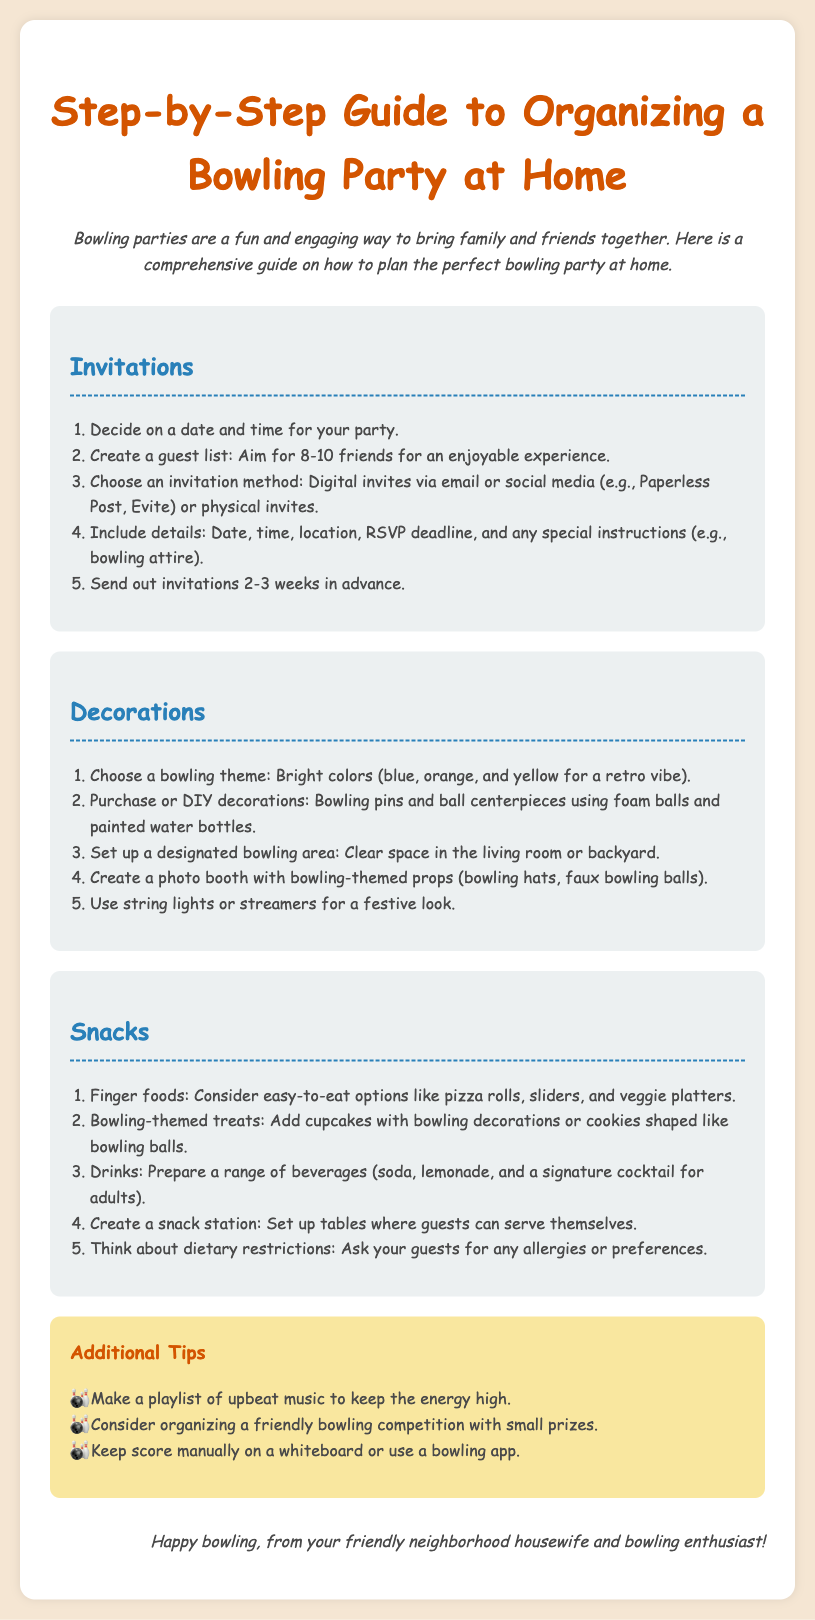What is the suggested number of friends for an enjoyable experience? The document suggests aiming for 8-10 friends for an enjoyable experience at the bowling party.
Answer: 8-10 friends What should you consider for decorations? The document mentions choosing a bowling theme with bright colors and DIY options like bowling pins and ball centerpieces.
Answer: Bowling theme When should invitations be sent out? The document recommends sending out invitations 2-3 weeks in advance of the party.
Answer: 2-3 weeks What type of food is mentioned as easy-to-eat options? The document lists pizza rolls, sliders, and veggie platters as examples of finger foods.
Answer: Pizza rolls What is one way to keep the energy high during the party? According to the document, making a playlist of upbeat music is a suggested way to keep the energy high at the party.
Answer: Playlist of upbeat music What should you ask your guests about regarding snacks? The document advises asking guests for any allergies or preferences related to snacks.
Answer: Allergies or preferences Which area of the house should be cleared for bowling? The recommendations include clearing space in the living room or backyard for the bowling area.
Answer: Living room or backyard What kind of props are suggested for the photo booth? The document suggests using bowling hats and faux bowling balls as props for the photo booth.
Answer: Bowling hats and faux bowling balls What is mentioned as a way to keep score? The document mentions using a whiteboard or a bowling app to keep score during the party.
Answer: Whiteboard or bowling app 